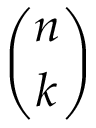<formula> <loc_0><loc_0><loc_500><loc_500>\binom { n } { k }</formula> 